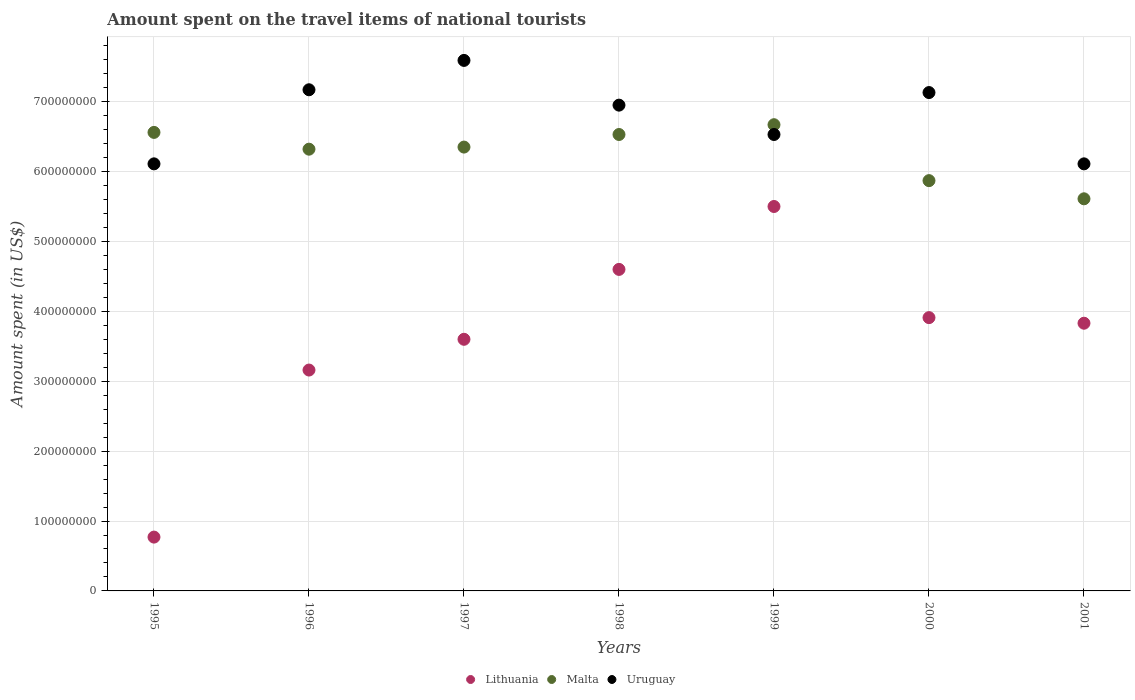Is the number of dotlines equal to the number of legend labels?
Offer a terse response. Yes. What is the amount spent on the travel items of national tourists in Uruguay in 2001?
Give a very brief answer. 6.11e+08. Across all years, what is the maximum amount spent on the travel items of national tourists in Lithuania?
Keep it short and to the point. 5.50e+08. Across all years, what is the minimum amount spent on the travel items of national tourists in Malta?
Your answer should be very brief. 5.61e+08. In which year was the amount spent on the travel items of national tourists in Uruguay maximum?
Provide a short and direct response. 1997. In which year was the amount spent on the travel items of national tourists in Lithuania minimum?
Provide a short and direct response. 1995. What is the total amount spent on the travel items of national tourists in Uruguay in the graph?
Ensure brevity in your answer.  4.76e+09. What is the difference between the amount spent on the travel items of national tourists in Malta in 1995 and that in 1998?
Your answer should be compact. 3.00e+06. What is the difference between the amount spent on the travel items of national tourists in Malta in 1997 and the amount spent on the travel items of national tourists in Lithuania in 2000?
Your answer should be very brief. 2.44e+08. What is the average amount spent on the travel items of national tourists in Lithuania per year?
Give a very brief answer. 3.62e+08. In the year 2001, what is the difference between the amount spent on the travel items of national tourists in Malta and amount spent on the travel items of national tourists in Lithuania?
Offer a very short reply. 1.78e+08. In how many years, is the amount spent on the travel items of national tourists in Lithuania greater than 760000000 US$?
Ensure brevity in your answer.  0. What is the ratio of the amount spent on the travel items of national tourists in Uruguay in 1998 to that in 2001?
Make the answer very short. 1.14. Is the amount spent on the travel items of national tourists in Malta in 1999 less than that in 2000?
Ensure brevity in your answer.  No. What is the difference between the highest and the second highest amount spent on the travel items of national tourists in Lithuania?
Keep it short and to the point. 9.00e+07. What is the difference between the highest and the lowest amount spent on the travel items of national tourists in Uruguay?
Make the answer very short. 1.48e+08. In how many years, is the amount spent on the travel items of national tourists in Uruguay greater than the average amount spent on the travel items of national tourists in Uruguay taken over all years?
Your answer should be very brief. 4. Is the sum of the amount spent on the travel items of national tourists in Malta in 1995 and 1997 greater than the maximum amount spent on the travel items of national tourists in Uruguay across all years?
Your answer should be compact. Yes. Is it the case that in every year, the sum of the amount spent on the travel items of national tourists in Malta and amount spent on the travel items of national tourists in Lithuania  is greater than the amount spent on the travel items of national tourists in Uruguay?
Make the answer very short. Yes. Does the graph contain any zero values?
Provide a succinct answer. No. Does the graph contain grids?
Your answer should be very brief. Yes. Where does the legend appear in the graph?
Give a very brief answer. Bottom center. How are the legend labels stacked?
Your response must be concise. Horizontal. What is the title of the graph?
Give a very brief answer. Amount spent on the travel items of national tourists. Does "Serbia" appear as one of the legend labels in the graph?
Keep it short and to the point. No. What is the label or title of the X-axis?
Ensure brevity in your answer.  Years. What is the label or title of the Y-axis?
Provide a succinct answer. Amount spent (in US$). What is the Amount spent (in US$) of Lithuania in 1995?
Keep it short and to the point. 7.70e+07. What is the Amount spent (in US$) of Malta in 1995?
Provide a short and direct response. 6.56e+08. What is the Amount spent (in US$) of Uruguay in 1995?
Keep it short and to the point. 6.11e+08. What is the Amount spent (in US$) of Lithuania in 1996?
Ensure brevity in your answer.  3.16e+08. What is the Amount spent (in US$) of Malta in 1996?
Give a very brief answer. 6.32e+08. What is the Amount spent (in US$) of Uruguay in 1996?
Ensure brevity in your answer.  7.17e+08. What is the Amount spent (in US$) of Lithuania in 1997?
Make the answer very short. 3.60e+08. What is the Amount spent (in US$) of Malta in 1997?
Provide a short and direct response. 6.35e+08. What is the Amount spent (in US$) in Uruguay in 1997?
Your response must be concise. 7.59e+08. What is the Amount spent (in US$) in Lithuania in 1998?
Give a very brief answer. 4.60e+08. What is the Amount spent (in US$) of Malta in 1998?
Ensure brevity in your answer.  6.53e+08. What is the Amount spent (in US$) in Uruguay in 1998?
Your answer should be very brief. 6.95e+08. What is the Amount spent (in US$) of Lithuania in 1999?
Offer a terse response. 5.50e+08. What is the Amount spent (in US$) in Malta in 1999?
Provide a succinct answer. 6.67e+08. What is the Amount spent (in US$) of Uruguay in 1999?
Provide a succinct answer. 6.53e+08. What is the Amount spent (in US$) in Lithuania in 2000?
Your answer should be very brief. 3.91e+08. What is the Amount spent (in US$) in Malta in 2000?
Keep it short and to the point. 5.87e+08. What is the Amount spent (in US$) of Uruguay in 2000?
Your answer should be compact. 7.13e+08. What is the Amount spent (in US$) of Lithuania in 2001?
Your answer should be compact. 3.83e+08. What is the Amount spent (in US$) of Malta in 2001?
Provide a short and direct response. 5.61e+08. What is the Amount spent (in US$) in Uruguay in 2001?
Ensure brevity in your answer.  6.11e+08. Across all years, what is the maximum Amount spent (in US$) of Lithuania?
Keep it short and to the point. 5.50e+08. Across all years, what is the maximum Amount spent (in US$) in Malta?
Your response must be concise. 6.67e+08. Across all years, what is the maximum Amount spent (in US$) of Uruguay?
Make the answer very short. 7.59e+08. Across all years, what is the minimum Amount spent (in US$) in Lithuania?
Offer a very short reply. 7.70e+07. Across all years, what is the minimum Amount spent (in US$) in Malta?
Your answer should be compact. 5.61e+08. Across all years, what is the minimum Amount spent (in US$) in Uruguay?
Provide a short and direct response. 6.11e+08. What is the total Amount spent (in US$) of Lithuania in the graph?
Your response must be concise. 2.54e+09. What is the total Amount spent (in US$) of Malta in the graph?
Provide a succinct answer. 4.39e+09. What is the total Amount spent (in US$) in Uruguay in the graph?
Your response must be concise. 4.76e+09. What is the difference between the Amount spent (in US$) of Lithuania in 1995 and that in 1996?
Your response must be concise. -2.39e+08. What is the difference between the Amount spent (in US$) of Malta in 1995 and that in 1996?
Offer a very short reply. 2.40e+07. What is the difference between the Amount spent (in US$) in Uruguay in 1995 and that in 1996?
Offer a very short reply. -1.06e+08. What is the difference between the Amount spent (in US$) of Lithuania in 1995 and that in 1997?
Give a very brief answer. -2.83e+08. What is the difference between the Amount spent (in US$) of Malta in 1995 and that in 1997?
Provide a succinct answer. 2.10e+07. What is the difference between the Amount spent (in US$) in Uruguay in 1995 and that in 1997?
Offer a very short reply. -1.48e+08. What is the difference between the Amount spent (in US$) of Lithuania in 1995 and that in 1998?
Keep it short and to the point. -3.83e+08. What is the difference between the Amount spent (in US$) in Uruguay in 1995 and that in 1998?
Your answer should be compact. -8.40e+07. What is the difference between the Amount spent (in US$) in Lithuania in 1995 and that in 1999?
Provide a short and direct response. -4.73e+08. What is the difference between the Amount spent (in US$) in Malta in 1995 and that in 1999?
Offer a very short reply. -1.10e+07. What is the difference between the Amount spent (in US$) of Uruguay in 1995 and that in 1999?
Offer a very short reply. -4.20e+07. What is the difference between the Amount spent (in US$) of Lithuania in 1995 and that in 2000?
Give a very brief answer. -3.14e+08. What is the difference between the Amount spent (in US$) in Malta in 1995 and that in 2000?
Offer a very short reply. 6.90e+07. What is the difference between the Amount spent (in US$) in Uruguay in 1995 and that in 2000?
Provide a short and direct response. -1.02e+08. What is the difference between the Amount spent (in US$) of Lithuania in 1995 and that in 2001?
Your answer should be compact. -3.06e+08. What is the difference between the Amount spent (in US$) in Malta in 1995 and that in 2001?
Provide a succinct answer. 9.50e+07. What is the difference between the Amount spent (in US$) of Lithuania in 1996 and that in 1997?
Your answer should be very brief. -4.40e+07. What is the difference between the Amount spent (in US$) of Uruguay in 1996 and that in 1997?
Keep it short and to the point. -4.20e+07. What is the difference between the Amount spent (in US$) of Lithuania in 1996 and that in 1998?
Your answer should be very brief. -1.44e+08. What is the difference between the Amount spent (in US$) of Malta in 1996 and that in 1998?
Provide a short and direct response. -2.10e+07. What is the difference between the Amount spent (in US$) of Uruguay in 1996 and that in 1998?
Your answer should be compact. 2.20e+07. What is the difference between the Amount spent (in US$) in Lithuania in 1996 and that in 1999?
Offer a terse response. -2.34e+08. What is the difference between the Amount spent (in US$) of Malta in 1996 and that in 1999?
Provide a short and direct response. -3.50e+07. What is the difference between the Amount spent (in US$) of Uruguay in 1996 and that in 1999?
Make the answer very short. 6.40e+07. What is the difference between the Amount spent (in US$) of Lithuania in 1996 and that in 2000?
Offer a very short reply. -7.50e+07. What is the difference between the Amount spent (in US$) of Malta in 1996 and that in 2000?
Provide a succinct answer. 4.50e+07. What is the difference between the Amount spent (in US$) of Uruguay in 1996 and that in 2000?
Ensure brevity in your answer.  4.00e+06. What is the difference between the Amount spent (in US$) in Lithuania in 1996 and that in 2001?
Provide a succinct answer. -6.70e+07. What is the difference between the Amount spent (in US$) of Malta in 1996 and that in 2001?
Offer a terse response. 7.10e+07. What is the difference between the Amount spent (in US$) in Uruguay in 1996 and that in 2001?
Keep it short and to the point. 1.06e+08. What is the difference between the Amount spent (in US$) in Lithuania in 1997 and that in 1998?
Keep it short and to the point. -1.00e+08. What is the difference between the Amount spent (in US$) in Malta in 1997 and that in 1998?
Your response must be concise. -1.80e+07. What is the difference between the Amount spent (in US$) in Uruguay in 1997 and that in 1998?
Provide a succinct answer. 6.40e+07. What is the difference between the Amount spent (in US$) in Lithuania in 1997 and that in 1999?
Provide a succinct answer. -1.90e+08. What is the difference between the Amount spent (in US$) in Malta in 1997 and that in 1999?
Keep it short and to the point. -3.20e+07. What is the difference between the Amount spent (in US$) in Uruguay in 1997 and that in 1999?
Provide a succinct answer. 1.06e+08. What is the difference between the Amount spent (in US$) of Lithuania in 1997 and that in 2000?
Your answer should be very brief. -3.10e+07. What is the difference between the Amount spent (in US$) in Malta in 1997 and that in 2000?
Keep it short and to the point. 4.80e+07. What is the difference between the Amount spent (in US$) of Uruguay in 1997 and that in 2000?
Your answer should be very brief. 4.60e+07. What is the difference between the Amount spent (in US$) in Lithuania in 1997 and that in 2001?
Provide a succinct answer. -2.30e+07. What is the difference between the Amount spent (in US$) in Malta in 1997 and that in 2001?
Provide a short and direct response. 7.40e+07. What is the difference between the Amount spent (in US$) in Uruguay in 1997 and that in 2001?
Offer a very short reply. 1.48e+08. What is the difference between the Amount spent (in US$) in Lithuania in 1998 and that in 1999?
Offer a very short reply. -9.00e+07. What is the difference between the Amount spent (in US$) in Malta in 1998 and that in 1999?
Make the answer very short. -1.40e+07. What is the difference between the Amount spent (in US$) in Uruguay in 1998 and that in 1999?
Provide a succinct answer. 4.20e+07. What is the difference between the Amount spent (in US$) of Lithuania in 1998 and that in 2000?
Keep it short and to the point. 6.90e+07. What is the difference between the Amount spent (in US$) in Malta in 1998 and that in 2000?
Make the answer very short. 6.60e+07. What is the difference between the Amount spent (in US$) in Uruguay in 1998 and that in 2000?
Give a very brief answer. -1.80e+07. What is the difference between the Amount spent (in US$) in Lithuania in 1998 and that in 2001?
Your response must be concise. 7.70e+07. What is the difference between the Amount spent (in US$) of Malta in 1998 and that in 2001?
Give a very brief answer. 9.20e+07. What is the difference between the Amount spent (in US$) in Uruguay in 1998 and that in 2001?
Give a very brief answer. 8.40e+07. What is the difference between the Amount spent (in US$) in Lithuania in 1999 and that in 2000?
Offer a terse response. 1.59e+08. What is the difference between the Amount spent (in US$) in Malta in 1999 and that in 2000?
Make the answer very short. 8.00e+07. What is the difference between the Amount spent (in US$) in Uruguay in 1999 and that in 2000?
Provide a succinct answer. -6.00e+07. What is the difference between the Amount spent (in US$) of Lithuania in 1999 and that in 2001?
Ensure brevity in your answer.  1.67e+08. What is the difference between the Amount spent (in US$) of Malta in 1999 and that in 2001?
Ensure brevity in your answer.  1.06e+08. What is the difference between the Amount spent (in US$) in Uruguay in 1999 and that in 2001?
Your response must be concise. 4.20e+07. What is the difference between the Amount spent (in US$) in Lithuania in 2000 and that in 2001?
Your answer should be compact. 8.00e+06. What is the difference between the Amount spent (in US$) in Malta in 2000 and that in 2001?
Provide a succinct answer. 2.60e+07. What is the difference between the Amount spent (in US$) in Uruguay in 2000 and that in 2001?
Ensure brevity in your answer.  1.02e+08. What is the difference between the Amount spent (in US$) of Lithuania in 1995 and the Amount spent (in US$) of Malta in 1996?
Provide a succinct answer. -5.55e+08. What is the difference between the Amount spent (in US$) in Lithuania in 1995 and the Amount spent (in US$) in Uruguay in 1996?
Your response must be concise. -6.40e+08. What is the difference between the Amount spent (in US$) of Malta in 1995 and the Amount spent (in US$) of Uruguay in 1996?
Offer a terse response. -6.10e+07. What is the difference between the Amount spent (in US$) in Lithuania in 1995 and the Amount spent (in US$) in Malta in 1997?
Offer a terse response. -5.58e+08. What is the difference between the Amount spent (in US$) of Lithuania in 1995 and the Amount spent (in US$) of Uruguay in 1997?
Your answer should be very brief. -6.82e+08. What is the difference between the Amount spent (in US$) of Malta in 1995 and the Amount spent (in US$) of Uruguay in 1997?
Your answer should be compact. -1.03e+08. What is the difference between the Amount spent (in US$) of Lithuania in 1995 and the Amount spent (in US$) of Malta in 1998?
Ensure brevity in your answer.  -5.76e+08. What is the difference between the Amount spent (in US$) of Lithuania in 1995 and the Amount spent (in US$) of Uruguay in 1998?
Provide a short and direct response. -6.18e+08. What is the difference between the Amount spent (in US$) of Malta in 1995 and the Amount spent (in US$) of Uruguay in 1998?
Provide a short and direct response. -3.90e+07. What is the difference between the Amount spent (in US$) in Lithuania in 1995 and the Amount spent (in US$) in Malta in 1999?
Your answer should be compact. -5.90e+08. What is the difference between the Amount spent (in US$) in Lithuania in 1995 and the Amount spent (in US$) in Uruguay in 1999?
Give a very brief answer. -5.76e+08. What is the difference between the Amount spent (in US$) of Lithuania in 1995 and the Amount spent (in US$) of Malta in 2000?
Offer a very short reply. -5.10e+08. What is the difference between the Amount spent (in US$) of Lithuania in 1995 and the Amount spent (in US$) of Uruguay in 2000?
Keep it short and to the point. -6.36e+08. What is the difference between the Amount spent (in US$) in Malta in 1995 and the Amount spent (in US$) in Uruguay in 2000?
Keep it short and to the point. -5.70e+07. What is the difference between the Amount spent (in US$) of Lithuania in 1995 and the Amount spent (in US$) of Malta in 2001?
Keep it short and to the point. -4.84e+08. What is the difference between the Amount spent (in US$) in Lithuania in 1995 and the Amount spent (in US$) in Uruguay in 2001?
Offer a very short reply. -5.34e+08. What is the difference between the Amount spent (in US$) of Malta in 1995 and the Amount spent (in US$) of Uruguay in 2001?
Offer a terse response. 4.50e+07. What is the difference between the Amount spent (in US$) of Lithuania in 1996 and the Amount spent (in US$) of Malta in 1997?
Your answer should be very brief. -3.19e+08. What is the difference between the Amount spent (in US$) in Lithuania in 1996 and the Amount spent (in US$) in Uruguay in 1997?
Make the answer very short. -4.43e+08. What is the difference between the Amount spent (in US$) in Malta in 1996 and the Amount spent (in US$) in Uruguay in 1997?
Ensure brevity in your answer.  -1.27e+08. What is the difference between the Amount spent (in US$) of Lithuania in 1996 and the Amount spent (in US$) of Malta in 1998?
Keep it short and to the point. -3.37e+08. What is the difference between the Amount spent (in US$) of Lithuania in 1996 and the Amount spent (in US$) of Uruguay in 1998?
Provide a succinct answer. -3.79e+08. What is the difference between the Amount spent (in US$) in Malta in 1996 and the Amount spent (in US$) in Uruguay in 1998?
Ensure brevity in your answer.  -6.30e+07. What is the difference between the Amount spent (in US$) in Lithuania in 1996 and the Amount spent (in US$) in Malta in 1999?
Give a very brief answer. -3.51e+08. What is the difference between the Amount spent (in US$) of Lithuania in 1996 and the Amount spent (in US$) of Uruguay in 1999?
Keep it short and to the point. -3.37e+08. What is the difference between the Amount spent (in US$) in Malta in 1996 and the Amount spent (in US$) in Uruguay in 1999?
Your response must be concise. -2.10e+07. What is the difference between the Amount spent (in US$) in Lithuania in 1996 and the Amount spent (in US$) in Malta in 2000?
Offer a terse response. -2.71e+08. What is the difference between the Amount spent (in US$) in Lithuania in 1996 and the Amount spent (in US$) in Uruguay in 2000?
Make the answer very short. -3.97e+08. What is the difference between the Amount spent (in US$) of Malta in 1996 and the Amount spent (in US$) of Uruguay in 2000?
Ensure brevity in your answer.  -8.10e+07. What is the difference between the Amount spent (in US$) of Lithuania in 1996 and the Amount spent (in US$) of Malta in 2001?
Give a very brief answer. -2.45e+08. What is the difference between the Amount spent (in US$) of Lithuania in 1996 and the Amount spent (in US$) of Uruguay in 2001?
Provide a succinct answer. -2.95e+08. What is the difference between the Amount spent (in US$) of Malta in 1996 and the Amount spent (in US$) of Uruguay in 2001?
Make the answer very short. 2.10e+07. What is the difference between the Amount spent (in US$) of Lithuania in 1997 and the Amount spent (in US$) of Malta in 1998?
Offer a terse response. -2.93e+08. What is the difference between the Amount spent (in US$) of Lithuania in 1997 and the Amount spent (in US$) of Uruguay in 1998?
Your answer should be very brief. -3.35e+08. What is the difference between the Amount spent (in US$) of Malta in 1997 and the Amount spent (in US$) of Uruguay in 1998?
Your answer should be very brief. -6.00e+07. What is the difference between the Amount spent (in US$) in Lithuania in 1997 and the Amount spent (in US$) in Malta in 1999?
Your answer should be compact. -3.07e+08. What is the difference between the Amount spent (in US$) in Lithuania in 1997 and the Amount spent (in US$) in Uruguay in 1999?
Your response must be concise. -2.93e+08. What is the difference between the Amount spent (in US$) of Malta in 1997 and the Amount spent (in US$) of Uruguay in 1999?
Offer a terse response. -1.80e+07. What is the difference between the Amount spent (in US$) in Lithuania in 1997 and the Amount spent (in US$) in Malta in 2000?
Make the answer very short. -2.27e+08. What is the difference between the Amount spent (in US$) in Lithuania in 1997 and the Amount spent (in US$) in Uruguay in 2000?
Offer a terse response. -3.53e+08. What is the difference between the Amount spent (in US$) of Malta in 1997 and the Amount spent (in US$) of Uruguay in 2000?
Ensure brevity in your answer.  -7.80e+07. What is the difference between the Amount spent (in US$) in Lithuania in 1997 and the Amount spent (in US$) in Malta in 2001?
Your answer should be very brief. -2.01e+08. What is the difference between the Amount spent (in US$) in Lithuania in 1997 and the Amount spent (in US$) in Uruguay in 2001?
Provide a short and direct response. -2.51e+08. What is the difference between the Amount spent (in US$) in Malta in 1997 and the Amount spent (in US$) in Uruguay in 2001?
Give a very brief answer. 2.40e+07. What is the difference between the Amount spent (in US$) in Lithuania in 1998 and the Amount spent (in US$) in Malta in 1999?
Your response must be concise. -2.07e+08. What is the difference between the Amount spent (in US$) in Lithuania in 1998 and the Amount spent (in US$) in Uruguay in 1999?
Offer a very short reply. -1.93e+08. What is the difference between the Amount spent (in US$) of Lithuania in 1998 and the Amount spent (in US$) of Malta in 2000?
Provide a short and direct response. -1.27e+08. What is the difference between the Amount spent (in US$) of Lithuania in 1998 and the Amount spent (in US$) of Uruguay in 2000?
Make the answer very short. -2.53e+08. What is the difference between the Amount spent (in US$) of Malta in 1998 and the Amount spent (in US$) of Uruguay in 2000?
Give a very brief answer. -6.00e+07. What is the difference between the Amount spent (in US$) of Lithuania in 1998 and the Amount spent (in US$) of Malta in 2001?
Provide a short and direct response. -1.01e+08. What is the difference between the Amount spent (in US$) of Lithuania in 1998 and the Amount spent (in US$) of Uruguay in 2001?
Provide a succinct answer. -1.51e+08. What is the difference between the Amount spent (in US$) in Malta in 1998 and the Amount spent (in US$) in Uruguay in 2001?
Offer a terse response. 4.20e+07. What is the difference between the Amount spent (in US$) of Lithuania in 1999 and the Amount spent (in US$) of Malta in 2000?
Ensure brevity in your answer.  -3.70e+07. What is the difference between the Amount spent (in US$) of Lithuania in 1999 and the Amount spent (in US$) of Uruguay in 2000?
Give a very brief answer. -1.63e+08. What is the difference between the Amount spent (in US$) of Malta in 1999 and the Amount spent (in US$) of Uruguay in 2000?
Make the answer very short. -4.60e+07. What is the difference between the Amount spent (in US$) in Lithuania in 1999 and the Amount spent (in US$) in Malta in 2001?
Provide a succinct answer. -1.10e+07. What is the difference between the Amount spent (in US$) of Lithuania in 1999 and the Amount spent (in US$) of Uruguay in 2001?
Your response must be concise. -6.10e+07. What is the difference between the Amount spent (in US$) of Malta in 1999 and the Amount spent (in US$) of Uruguay in 2001?
Your answer should be compact. 5.60e+07. What is the difference between the Amount spent (in US$) in Lithuania in 2000 and the Amount spent (in US$) in Malta in 2001?
Ensure brevity in your answer.  -1.70e+08. What is the difference between the Amount spent (in US$) of Lithuania in 2000 and the Amount spent (in US$) of Uruguay in 2001?
Provide a succinct answer. -2.20e+08. What is the difference between the Amount spent (in US$) of Malta in 2000 and the Amount spent (in US$) of Uruguay in 2001?
Ensure brevity in your answer.  -2.40e+07. What is the average Amount spent (in US$) in Lithuania per year?
Offer a terse response. 3.62e+08. What is the average Amount spent (in US$) in Malta per year?
Offer a terse response. 6.27e+08. What is the average Amount spent (in US$) in Uruguay per year?
Ensure brevity in your answer.  6.80e+08. In the year 1995, what is the difference between the Amount spent (in US$) in Lithuania and Amount spent (in US$) in Malta?
Keep it short and to the point. -5.79e+08. In the year 1995, what is the difference between the Amount spent (in US$) in Lithuania and Amount spent (in US$) in Uruguay?
Offer a terse response. -5.34e+08. In the year 1995, what is the difference between the Amount spent (in US$) in Malta and Amount spent (in US$) in Uruguay?
Your answer should be compact. 4.50e+07. In the year 1996, what is the difference between the Amount spent (in US$) in Lithuania and Amount spent (in US$) in Malta?
Make the answer very short. -3.16e+08. In the year 1996, what is the difference between the Amount spent (in US$) of Lithuania and Amount spent (in US$) of Uruguay?
Your response must be concise. -4.01e+08. In the year 1996, what is the difference between the Amount spent (in US$) of Malta and Amount spent (in US$) of Uruguay?
Ensure brevity in your answer.  -8.50e+07. In the year 1997, what is the difference between the Amount spent (in US$) of Lithuania and Amount spent (in US$) of Malta?
Offer a very short reply. -2.75e+08. In the year 1997, what is the difference between the Amount spent (in US$) of Lithuania and Amount spent (in US$) of Uruguay?
Give a very brief answer. -3.99e+08. In the year 1997, what is the difference between the Amount spent (in US$) of Malta and Amount spent (in US$) of Uruguay?
Keep it short and to the point. -1.24e+08. In the year 1998, what is the difference between the Amount spent (in US$) in Lithuania and Amount spent (in US$) in Malta?
Offer a terse response. -1.93e+08. In the year 1998, what is the difference between the Amount spent (in US$) in Lithuania and Amount spent (in US$) in Uruguay?
Your response must be concise. -2.35e+08. In the year 1998, what is the difference between the Amount spent (in US$) in Malta and Amount spent (in US$) in Uruguay?
Give a very brief answer. -4.20e+07. In the year 1999, what is the difference between the Amount spent (in US$) in Lithuania and Amount spent (in US$) in Malta?
Your answer should be compact. -1.17e+08. In the year 1999, what is the difference between the Amount spent (in US$) of Lithuania and Amount spent (in US$) of Uruguay?
Make the answer very short. -1.03e+08. In the year 1999, what is the difference between the Amount spent (in US$) of Malta and Amount spent (in US$) of Uruguay?
Ensure brevity in your answer.  1.40e+07. In the year 2000, what is the difference between the Amount spent (in US$) of Lithuania and Amount spent (in US$) of Malta?
Provide a short and direct response. -1.96e+08. In the year 2000, what is the difference between the Amount spent (in US$) in Lithuania and Amount spent (in US$) in Uruguay?
Provide a succinct answer. -3.22e+08. In the year 2000, what is the difference between the Amount spent (in US$) of Malta and Amount spent (in US$) of Uruguay?
Your answer should be compact. -1.26e+08. In the year 2001, what is the difference between the Amount spent (in US$) in Lithuania and Amount spent (in US$) in Malta?
Provide a short and direct response. -1.78e+08. In the year 2001, what is the difference between the Amount spent (in US$) in Lithuania and Amount spent (in US$) in Uruguay?
Provide a succinct answer. -2.28e+08. In the year 2001, what is the difference between the Amount spent (in US$) of Malta and Amount spent (in US$) of Uruguay?
Ensure brevity in your answer.  -5.00e+07. What is the ratio of the Amount spent (in US$) of Lithuania in 1995 to that in 1996?
Offer a very short reply. 0.24. What is the ratio of the Amount spent (in US$) of Malta in 1995 to that in 1996?
Give a very brief answer. 1.04. What is the ratio of the Amount spent (in US$) in Uruguay in 1995 to that in 1996?
Offer a very short reply. 0.85. What is the ratio of the Amount spent (in US$) of Lithuania in 1995 to that in 1997?
Offer a very short reply. 0.21. What is the ratio of the Amount spent (in US$) of Malta in 1995 to that in 1997?
Keep it short and to the point. 1.03. What is the ratio of the Amount spent (in US$) of Uruguay in 1995 to that in 1997?
Offer a terse response. 0.81. What is the ratio of the Amount spent (in US$) of Lithuania in 1995 to that in 1998?
Provide a succinct answer. 0.17. What is the ratio of the Amount spent (in US$) of Malta in 1995 to that in 1998?
Your answer should be very brief. 1. What is the ratio of the Amount spent (in US$) in Uruguay in 1995 to that in 1998?
Provide a succinct answer. 0.88. What is the ratio of the Amount spent (in US$) in Lithuania in 1995 to that in 1999?
Your answer should be very brief. 0.14. What is the ratio of the Amount spent (in US$) in Malta in 1995 to that in 1999?
Your answer should be compact. 0.98. What is the ratio of the Amount spent (in US$) of Uruguay in 1995 to that in 1999?
Offer a very short reply. 0.94. What is the ratio of the Amount spent (in US$) of Lithuania in 1995 to that in 2000?
Give a very brief answer. 0.2. What is the ratio of the Amount spent (in US$) in Malta in 1995 to that in 2000?
Offer a terse response. 1.12. What is the ratio of the Amount spent (in US$) of Uruguay in 1995 to that in 2000?
Your answer should be very brief. 0.86. What is the ratio of the Amount spent (in US$) in Lithuania in 1995 to that in 2001?
Make the answer very short. 0.2. What is the ratio of the Amount spent (in US$) of Malta in 1995 to that in 2001?
Keep it short and to the point. 1.17. What is the ratio of the Amount spent (in US$) in Lithuania in 1996 to that in 1997?
Your answer should be very brief. 0.88. What is the ratio of the Amount spent (in US$) in Malta in 1996 to that in 1997?
Provide a succinct answer. 1. What is the ratio of the Amount spent (in US$) in Uruguay in 1996 to that in 1997?
Your response must be concise. 0.94. What is the ratio of the Amount spent (in US$) of Lithuania in 1996 to that in 1998?
Provide a succinct answer. 0.69. What is the ratio of the Amount spent (in US$) of Malta in 1996 to that in 1998?
Make the answer very short. 0.97. What is the ratio of the Amount spent (in US$) of Uruguay in 1996 to that in 1998?
Your answer should be compact. 1.03. What is the ratio of the Amount spent (in US$) in Lithuania in 1996 to that in 1999?
Your response must be concise. 0.57. What is the ratio of the Amount spent (in US$) of Malta in 1996 to that in 1999?
Your answer should be very brief. 0.95. What is the ratio of the Amount spent (in US$) of Uruguay in 1996 to that in 1999?
Ensure brevity in your answer.  1.1. What is the ratio of the Amount spent (in US$) of Lithuania in 1996 to that in 2000?
Provide a succinct answer. 0.81. What is the ratio of the Amount spent (in US$) of Malta in 1996 to that in 2000?
Make the answer very short. 1.08. What is the ratio of the Amount spent (in US$) of Uruguay in 1996 to that in 2000?
Your response must be concise. 1.01. What is the ratio of the Amount spent (in US$) in Lithuania in 1996 to that in 2001?
Offer a terse response. 0.83. What is the ratio of the Amount spent (in US$) in Malta in 1996 to that in 2001?
Provide a short and direct response. 1.13. What is the ratio of the Amount spent (in US$) in Uruguay in 1996 to that in 2001?
Give a very brief answer. 1.17. What is the ratio of the Amount spent (in US$) in Lithuania in 1997 to that in 1998?
Your answer should be very brief. 0.78. What is the ratio of the Amount spent (in US$) in Malta in 1997 to that in 1998?
Your response must be concise. 0.97. What is the ratio of the Amount spent (in US$) in Uruguay in 1997 to that in 1998?
Keep it short and to the point. 1.09. What is the ratio of the Amount spent (in US$) in Lithuania in 1997 to that in 1999?
Offer a terse response. 0.65. What is the ratio of the Amount spent (in US$) of Malta in 1997 to that in 1999?
Ensure brevity in your answer.  0.95. What is the ratio of the Amount spent (in US$) in Uruguay in 1997 to that in 1999?
Offer a very short reply. 1.16. What is the ratio of the Amount spent (in US$) of Lithuania in 1997 to that in 2000?
Offer a very short reply. 0.92. What is the ratio of the Amount spent (in US$) in Malta in 1997 to that in 2000?
Your answer should be very brief. 1.08. What is the ratio of the Amount spent (in US$) of Uruguay in 1997 to that in 2000?
Your response must be concise. 1.06. What is the ratio of the Amount spent (in US$) in Lithuania in 1997 to that in 2001?
Make the answer very short. 0.94. What is the ratio of the Amount spent (in US$) of Malta in 1997 to that in 2001?
Your answer should be compact. 1.13. What is the ratio of the Amount spent (in US$) in Uruguay in 1997 to that in 2001?
Offer a very short reply. 1.24. What is the ratio of the Amount spent (in US$) in Lithuania in 1998 to that in 1999?
Provide a short and direct response. 0.84. What is the ratio of the Amount spent (in US$) of Uruguay in 1998 to that in 1999?
Keep it short and to the point. 1.06. What is the ratio of the Amount spent (in US$) in Lithuania in 1998 to that in 2000?
Make the answer very short. 1.18. What is the ratio of the Amount spent (in US$) of Malta in 1998 to that in 2000?
Offer a terse response. 1.11. What is the ratio of the Amount spent (in US$) of Uruguay in 1998 to that in 2000?
Provide a succinct answer. 0.97. What is the ratio of the Amount spent (in US$) in Lithuania in 1998 to that in 2001?
Offer a very short reply. 1.2. What is the ratio of the Amount spent (in US$) of Malta in 1998 to that in 2001?
Provide a short and direct response. 1.16. What is the ratio of the Amount spent (in US$) of Uruguay in 1998 to that in 2001?
Offer a terse response. 1.14. What is the ratio of the Amount spent (in US$) in Lithuania in 1999 to that in 2000?
Keep it short and to the point. 1.41. What is the ratio of the Amount spent (in US$) of Malta in 1999 to that in 2000?
Your answer should be compact. 1.14. What is the ratio of the Amount spent (in US$) of Uruguay in 1999 to that in 2000?
Give a very brief answer. 0.92. What is the ratio of the Amount spent (in US$) of Lithuania in 1999 to that in 2001?
Offer a very short reply. 1.44. What is the ratio of the Amount spent (in US$) in Malta in 1999 to that in 2001?
Make the answer very short. 1.19. What is the ratio of the Amount spent (in US$) in Uruguay in 1999 to that in 2001?
Provide a short and direct response. 1.07. What is the ratio of the Amount spent (in US$) of Lithuania in 2000 to that in 2001?
Provide a succinct answer. 1.02. What is the ratio of the Amount spent (in US$) of Malta in 2000 to that in 2001?
Your response must be concise. 1.05. What is the ratio of the Amount spent (in US$) of Uruguay in 2000 to that in 2001?
Provide a succinct answer. 1.17. What is the difference between the highest and the second highest Amount spent (in US$) of Lithuania?
Your response must be concise. 9.00e+07. What is the difference between the highest and the second highest Amount spent (in US$) of Malta?
Provide a succinct answer. 1.10e+07. What is the difference between the highest and the second highest Amount spent (in US$) in Uruguay?
Make the answer very short. 4.20e+07. What is the difference between the highest and the lowest Amount spent (in US$) of Lithuania?
Your response must be concise. 4.73e+08. What is the difference between the highest and the lowest Amount spent (in US$) in Malta?
Provide a short and direct response. 1.06e+08. What is the difference between the highest and the lowest Amount spent (in US$) in Uruguay?
Your response must be concise. 1.48e+08. 